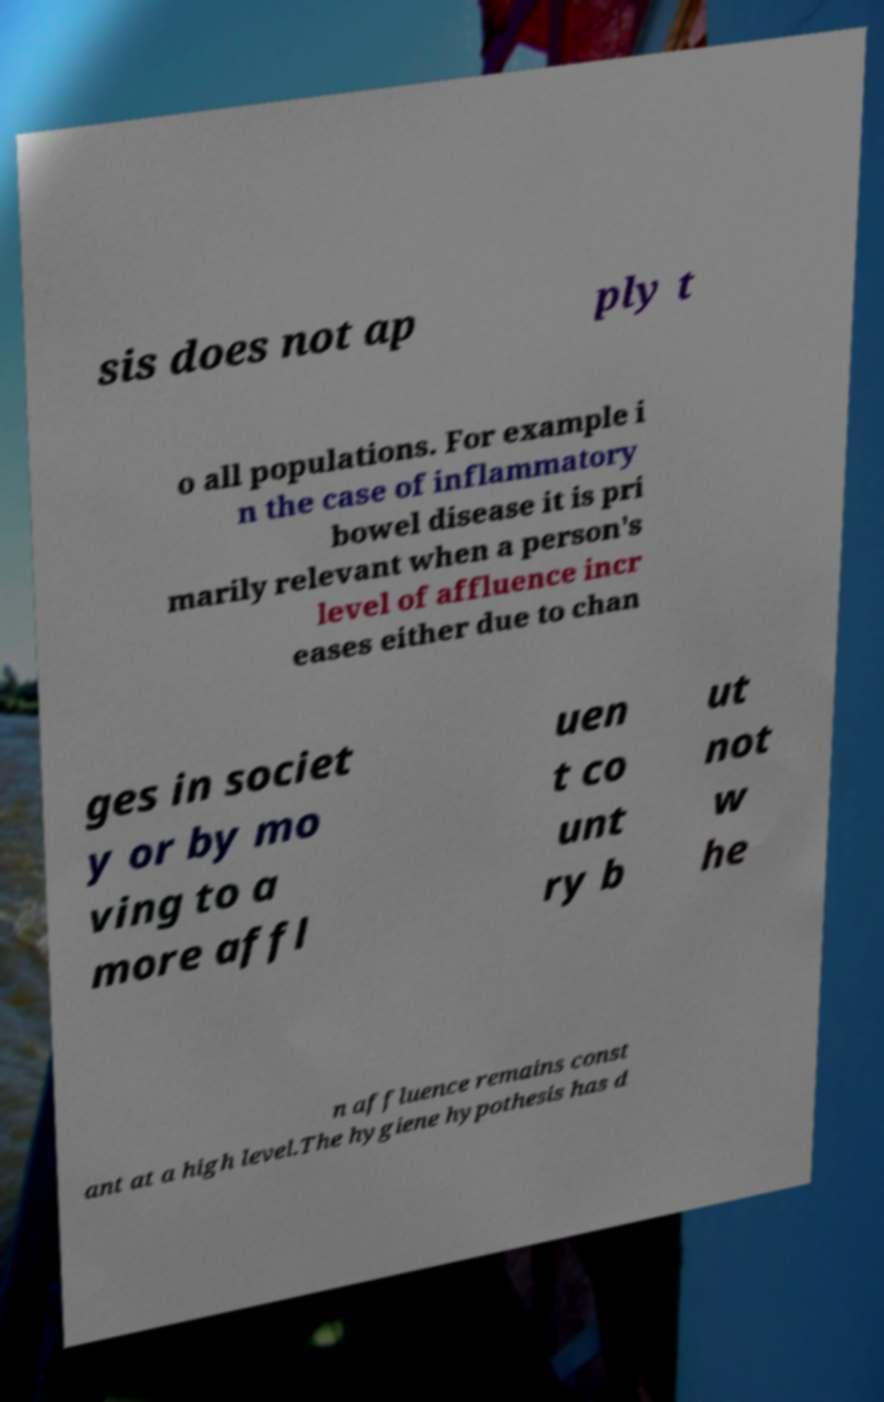Can you read and provide the text displayed in the image?This photo seems to have some interesting text. Can you extract and type it out for me? sis does not ap ply t o all populations. For example i n the case of inflammatory bowel disease it is pri marily relevant when a person's level of affluence incr eases either due to chan ges in societ y or by mo ving to a more affl uen t co unt ry b ut not w he n affluence remains const ant at a high level.The hygiene hypothesis has d 